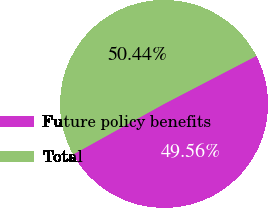Convert chart. <chart><loc_0><loc_0><loc_500><loc_500><pie_chart><fcel>Future policy benefits<fcel>Total<nl><fcel>49.56%<fcel>50.44%<nl></chart> 